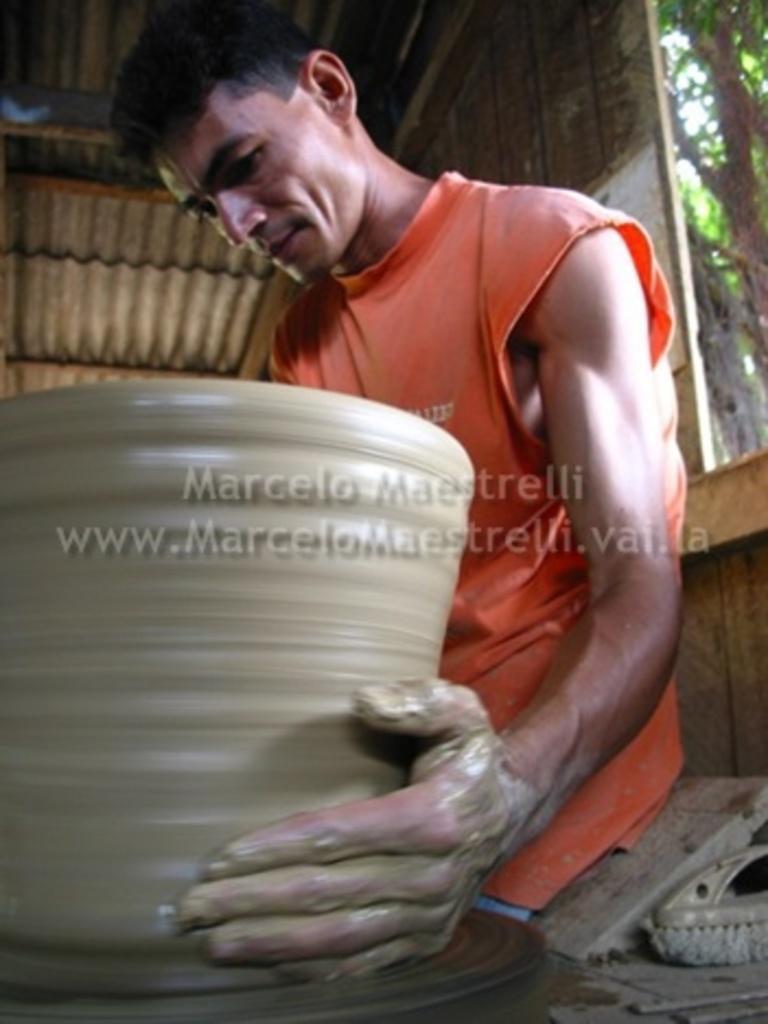Could you give a brief overview of what you see in this image? This image consists of a man wearing an orange T-shirt. He is making a pot with the mud. At the top, there is roof. On the right, we can see a window and a tree. 